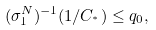Convert formula to latex. <formula><loc_0><loc_0><loc_500><loc_500>( \sigma _ { 1 } ^ { N } ) ^ { - 1 } ( 1 / C _ { ^ { * } } ) \leq q _ { 0 } ,</formula> 